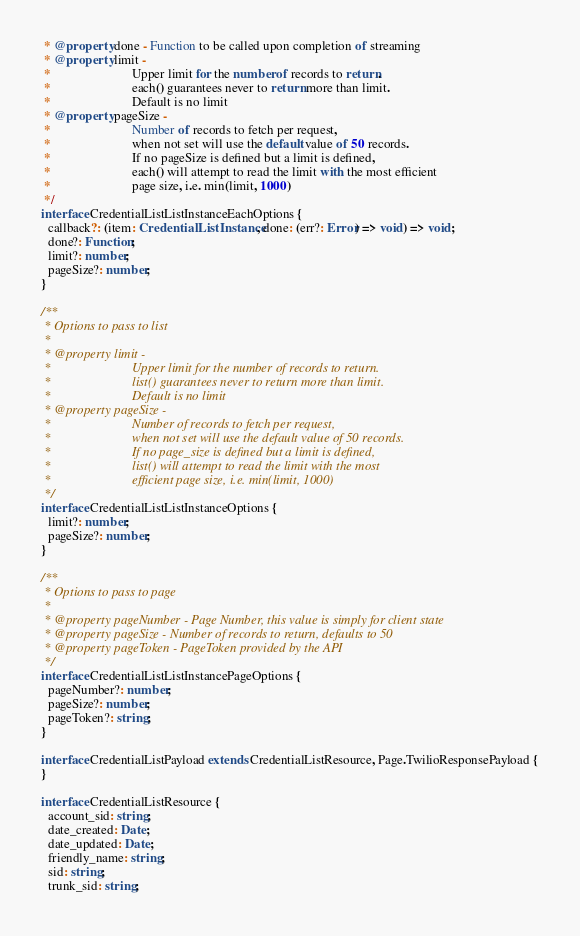<code> <loc_0><loc_0><loc_500><loc_500><_TypeScript_> * @property done - Function to be called upon completion of streaming
 * @property limit -
 *                         Upper limit for the number of records to return.
 *                         each() guarantees never to return more than limit.
 *                         Default is no limit
 * @property pageSize -
 *                         Number of records to fetch per request,
 *                         when not set will use the default value of 50 records.
 *                         If no pageSize is defined but a limit is defined,
 *                         each() will attempt to read the limit with the most efficient
 *                         page size, i.e. min(limit, 1000)
 */
interface CredentialListListInstanceEachOptions {
  callback?: (item: CredentialListInstance, done: (err?: Error) => void) => void;
  done?: Function;
  limit?: number;
  pageSize?: number;
}

/**
 * Options to pass to list
 *
 * @property limit -
 *                         Upper limit for the number of records to return.
 *                         list() guarantees never to return more than limit.
 *                         Default is no limit
 * @property pageSize -
 *                         Number of records to fetch per request,
 *                         when not set will use the default value of 50 records.
 *                         If no page_size is defined but a limit is defined,
 *                         list() will attempt to read the limit with the most
 *                         efficient page size, i.e. min(limit, 1000)
 */
interface CredentialListListInstanceOptions {
  limit?: number;
  pageSize?: number;
}

/**
 * Options to pass to page
 *
 * @property pageNumber - Page Number, this value is simply for client state
 * @property pageSize - Number of records to return, defaults to 50
 * @property pageToken - PageToken provided by the API
 */
interface CredentialListListInstancePageOptions {
  pageNumber?: number;
  pageSize?: number;
  pageToken?: string;
}

interface CredentialListPayload extends CredentialListResource, Page.TwilioResponsePayload {
}

interface CredentialListResource {
  account_sid: string;
  date_created: Date;
  date_updated: Date;
  friendly_name: string;
  sid: string;
  trunk_sid: string;</code> 